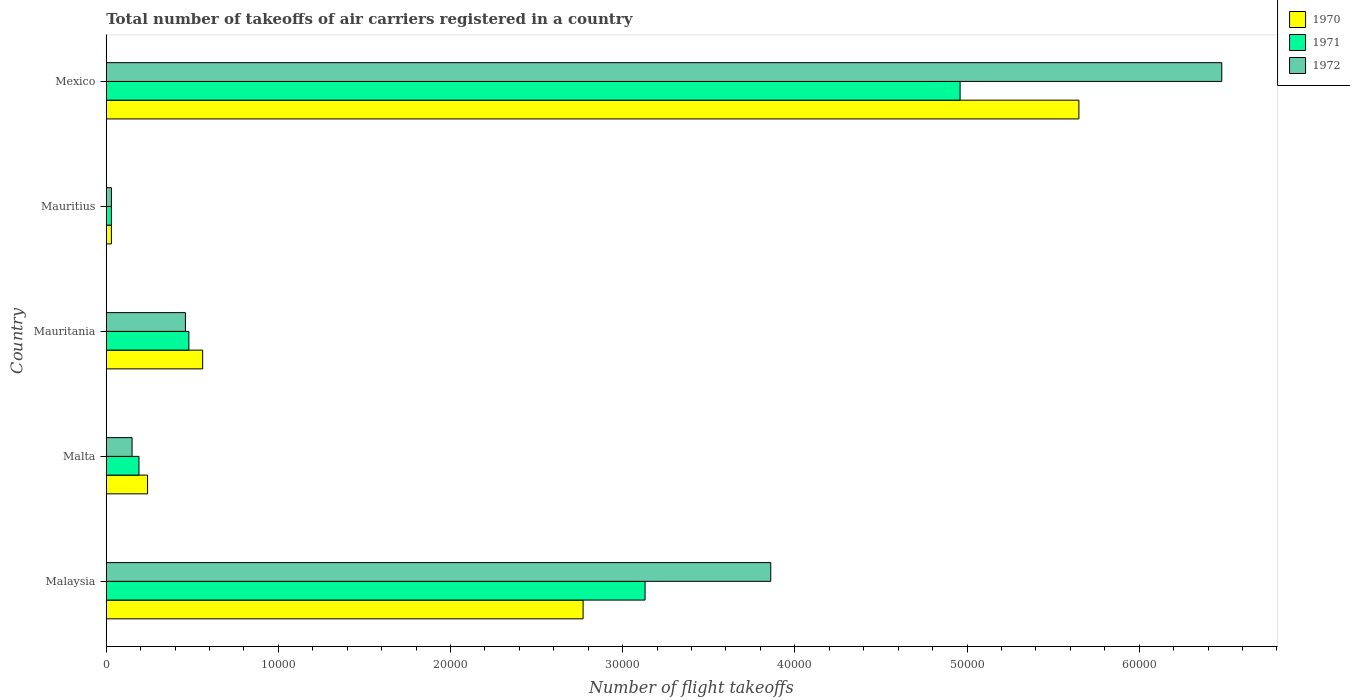Are the number of bars per tick equal to the number of legend labels?
Offer a very short reply. Yes. How many bars are there on the 4th tick from the top?
Ensure brevity in your answer.  3. How many bars are there on the 2nd tick from the bottom?
Offer a terse response. 3. What is the label of the 1st group of bars from the top?
Your answer should be very brief. Mexico. What is the total number of flight takeoffs in 1972 in Mauritania?
Offer a very short reply. 4600. Across all countries, what is the maximum total number of flight takeoffs in 1972?
Make the answer very short. 6.48e+04. Across all countries, what is the minimum total number of flight takeoffs in 1970?
Make the answer very short. 300. In which country was the total number of flight takeoffs in 1970 minimum?
Your answer should be compact. Mauritius. What is the total total number of flight takeoffs in 1971 in the graph?
Your answer should be compact. 8.79e+04. What is the difference between the total number of flight takeoffs in 1970 in Mauritius and that in Mexico?
Your answer should be very brief. -5.62e+04. What is the difference between the total number of flight takeoffs in 1971 in Malta and the total number of flight takeoffs in 1972 in Mexico?
Your answer should be compact. -6.29e+04. What is the average total number of flight takeoffs in 1972 per country?
Give a very brief answer. 2.20e+04. What is the difference between the total number of flight takeoffs in 1972 and total number of flight takeoffs in 1970 in Malta?
Give a very brief answer. -900. What is the ratio of the total number of flight takeoffs in 1970 in Malaysia to that in Mexico?
Keep it short and to the point. 0.49. Is the total number of flight takeoffs in 1971 in Malta less than that in Mexico?
Make the answer very short. Yes. What is the difference between the highest and the second highest total number of flight takeoffs in 1971?
Offer a very short reply. 1.83e+04. What is the difference between the highest and the lowest total number of flight takeoffs in 1970?
Your answer should be compact. 5.62e+04. In how many countries, is the total number of flight takeoffs in 1971 greater than the average total number of flight takeoffs in 1971 taken over all countries?
Keep it short and to the point. 2. Is the sum of the total number of flight takeoffs in 1971 in Mauritius and Mexico greater than the maximum total number of flight takeoffs in 1972 across all countries?
Your answer should be compact. No. What does the 2nd bar from the top in Malaysia represents?
Provide a short and direct response. 1971. What does the 2nd bar from the bottom in Malaysia represents?
Your answer should be compact. 1971. How many bars are there?
Your response must be concise. 15. Are all the bars in the graph horizontal?
Offer a terse response. Yes. How many countries are there in the graph?
Keep it short and to the point. 5. What is the difference between two consecutive major ticks on the X-axis?
Offer a terse response. 10000. Are the values on the major ticks of X-axis written in scientific E-notation?
Keep it short and to the point. No. Does the graph contain any zero values?
Offer a very short reply. No. Where does the legend appear in the graph?
Provide a short and direct response. Top right. How many legend labels are there?
Your response must be concise. 3. What is the title of the graph?
Keep it short and to the point. Total number of takeoffs of air carriers registered in a country. What is the label or title of the X-axis?
Provide a short and direct response. Number of flight takeoffs. What is the label or title of the Y-axis?
Offer a terse response. Country. What is the Number of flight takeoffs in 1970 in Malaysia?
Your answer should be compact. 2.77e+04. What is the Number of flight takeoffs in 1971 in Malaysia?
Make the answer very short. 3.13e+04. What is the Number of flight takeoffs in 1972 in Malaysia?
Your answer should be very brief. 3.86e+04. What is the Number of flight takeoffs of 1970 in Malta?
Your answer should be very brief. 2400. What is the Number of flight takeoffs of 1971 in Malta?
Keep it short and to the point. 1900. What is the Number of flight takeoffs of 1972 in Malta?
Keep it short and to the point. 1500. What is the Number of flight takeoffs in 1970 in Mauritania?
Provide a short and direct response. 5600. What is the Number of flight takeoffs of 1971 in Mauritania?
Make the answer very short. 4800. What is the Number of flight takeoffs in 1972 in Mauritania?
Provide a short and direct response. 4600. What is the Number of flight takeoffs in 1970 in Mauritius?
Provide a succinct answer. 300. What is the Number of flight takeoffs in 1971 in Mauritius?
Your response must be concise. 300. What is the Number of flight takeoffs in 1972 in Mauritius?
Give a very brief answer. 300. What is the Number of flight takeoffs of 1970 in Mexico?
Your response must be concise. 5.65e+04. What is the Number of flight takeoffs in 1971 in Mexico?
Your response must be concise. 4.96e+04. What is the Number of flight takeoffs of 1972 in Mexico?
Offer a terse response. 6.48e+04. Across all countries, what is the maximum Number of flight takeoffs of 1970?
Make the answer very short. 5.65e+04. Across all countries, what is the maximum Number of flight takeoffs of 1971?
Offer a very short reply. 4.96e+04. Across all countries, what is the maximum Number of flight takeoffs in 1972?
Offer a terse response. 6.48e+04. Across all countries, what is the minimum Number of flight takeoffs in 1970?
Offer a very short reply. 300. Across all countries, what is the minimum Number of flight takeoffs of 1971?
Your answer should be very brief. 300. Across all countries, what is the minimum Number of flight takeoffs of 1972?
Your answer should be compact. 300. What is the total Number of flight takeoffs in 1970 in the graph?
Offer a terse response. 9.25e+04. What is the total Number of flight takeoffs in 1971 in the graph?
Provide a succinct answer. 8.79e+04. What is the total Number of flight takeoffs of 1972 in the graph?
Provide a short and direct response. 1.10e+05. What is the difference between the Number of flight takeoffs of 1970 in Malaysia and that in Malta?
Your answer should be very brief. 2.53e+04. What is the difference between the Number of flight takeoffs of 1971 in Malaysia and that in Malta?
Keep it short and to the point. 2.94e+04. What is the difference between the Number of flight takeoffs of 1972 in Malaysia and that in Malta?
Your answer should be very brief. 3.71e+04. What is the difference between the Number of flight takeoffs in 1970 in Malaysia and that in Mauritania?
Provide a succinct answer. 2.21e+04. What is the difference between the Number of flight takeoffs in 1971 in Malaysia and that in Mauritania?
Give a very brief answer. 2.65e+04. What is the difference between the Number of flight takeoffs in 1972 in Malaysia and that in Mauritania?
Your answer should be compact. 3.40e+04. What is the difference between the Number of flight takeoffs of 1970 in Malaysia and that in Mauritius?
Ensure brevity in your answer.  2.74e+04. What is the difference between the Number of flight takeoffs in 1971 in Malaysia and that in Mauritius?
Your answer should be compact. 3.10e+04. What is the difference between the Number of flight takeoffs of 1972 in Malaysia and that in Mauritius?
Give a very brief answer. 3.83e+04. What is the difference between the Number of flight takeoffs of 1970 in Malaysia and that in Mexico?
Your answer should be very brief. -2.88e+04. What is the difference between the Number of flight takeoffs of 1971 in Malaysia and that in Mexico?
Make the answer very short. -1.83e+04. What is the difference between the Number of flight takeoffs of 1972 in Malaysia and that in Mexico?
Keep it short and to the point. -2.62e+04. What is the difference between the Number of flight takeoffs of 1970 in Malta and that in Mauritania?
Keep it short and to the point. -3200. What is the difference between the Number of flight takeoffs of 1971 in Malta and that in Mauritania?
Keep it short and to the point. -2900. What is the difference between the Number of flight takeoffs of 1972 in Malta and that in Mauritania?
Your answer should be very brief. -3100. What is the difference between the Number of flight takeoffs of 1970 in Malta and that in Mauritius?
Keep it short and to the point. 2100. What is the difference between the Number of flight takeoffs of 1971 in Malta and that in Mauritius?
Provide a succinct answer. 1600. What is the difference between the Number of flight takeoffs of 1972 in Malta and that in Mauritius?
Keep it short and to the point. 1200. What is the difference between the Number of flight takeoffs in 1970 in Malta and that in Mexico?
Ensure brevity in your answer.  -5.41e+04. What is the difference between the Number of flight takeoffs of 1971 in Malta and that in Mexico?
Offer a very short reply. -4.77e+04. What is the difference between the Number of flight takeoffs of 1972 in Malta and that in Mexico?
Your answer should be compact. -6.33e+04. What is the difference between the Number of flight takeoffs in 1970 in Mauritania and that in Mauritius?
Keep it short and to the point. 5300. What is the difference between the Number of flight takeoffs in 1971 in Mauritania and that in Mauritius?
Your answer should be compact. 4500. What is the difference between the Number of flight takeoffs of 1972 in Mauritania and that in Mauritius?
Make the answer very short. 4300. What is the difference between the Number of flight takeoffs in 1970 in Mauritania and that in Mexico?
Offer a terse response. -5.09e+04. What is the difference between the Number of flight takeoffs of 1971 in Mauritania and that in Mexico?
Keep it short and to the point. -4.48e+04. What is the difference between the Number of flight takeoffs of 1972 in Mauritania and that in Mexico?
Offer a very short reply. -6.02e+04. What is the difference between the Number of flight takeoffs of 1970 in Mauritius and that in Mexico?
Your answer should be compact. -5.62e+04. What is the difference between the Number of flight takeoffs in 1971 in Mauritius and that in Mexico?
Your response must be concise. -4.93e+04. What is the difference between the Number of flight takeoffs in 1972 in Mauritius and that in Mexico?
Provide a succinct answer. -6.45e+04. What is the difference between the Number of flight takeoffs in 1970 in Malaysia and the Number of flight takeoffs in 1971 in Malta?
Offer a very short reply. 2.58e+04. What is the difference between the Number of flight takeoffs in 1970 in Malaysia and the Number of flight takeoffs in 1972 in Malta?
Your answer should be compact. 2.62e+04. What is the difference between the Number of flight takeoffs in 1971 in Malaysia and the Number of flight takeoffs in 1972 in Malta?
Give a very brief answer. 2.98e+04. What is the difference between the Number of flight takeoffs of 1970 in Malaysia and the Number of flight takeoffs of 1971 in Mauritania?
Provide a short and direct response. 2.29e+04. What is the difference between the Number of flight takeoffs of 1970 in Malaysia and the Number of flight takeoffs of 1972 in Mauritania?
Your response must be concise. 2.31e+04. What is the difference between the Number of flight takeoffs in 1971 in Malaysia and the Number of flight takeoffs in 1972 in Mauritania?
Offer a very short reply. 2.67e+04. What is the difference between the Number of flight takeoffs in 1970 in Malaysia and the Number of flight takeoffs in 1971 in Mauritius?
Offer a terse response. 2.74e+04. What is the difference between the Number of flight takeoffs of 1970 in Malaysia and the Number of flight takeoffs of 1972 in Mauritius?
Give a very brief answer. 2.74e+04. What is the difference between the Number of flight takeoffs in 1971 in Malaysia and the Number of flight takeoffs in 1972 in Mauritius?
Offer a terse response. 3.10e+04. What is the difference between the Number of flight takeoffs of 1970 in Malaysia and the Number of flight takeoffs of 1971 in Mexico?
Offer a very short reply. -2.19e+04. What is the difference between the Number of flight takeoffs in 1970 in Malaysia and the Number of flight takeoffs in 1972 in Mexico?
Offer a very short reply. -3.71e+04. What is the difference between the Number of flight takeoffs of 1971 in Malaysia and the Number of flight takeoffs of 1972 in Mexico?
Keep it short and to the point. -3.35e+04. What is the difference between the Number of flight takeoffs in 1970 in Malta and the Number of flight takeoffs in 1971 in Mauritania?
Ensure brevity in your answer.  -2400. What is the difference between the Number of flight takeoffs in 1970 in Malta and the Number of flight takeoffs in 1972 in Mauritania?
Your response must be concise. -2200. What is the difference between the Number of flight takeoffs of 1971 in Malta and the Number of flight takeoffs of 1972 in Mauritania?
Offer a terse response. -2700. What is the difference between the Number of flight takeoffs of 1970 in Malta and the Number of flight takeoffs of 1971 in Mauritius?
Provide a short and direct response. 2100. What is the difference between the Number of flight takeoffs in 1970 in Malta and the Number of flight takeoffs in 1972 in Mauritius?
Give a very brief answer. 2100. What is the difference between the Number of flight takeoffs in 1971 in Malta and the Number of flight takeoffs in 1972 in Mauritius?
Ensure brevity in your answer.  1600. What is the difference between the Number of flight takeoffs in 1970 in Malta and the Number of flight takeoffs in 1971 in Mexico?
Offer a terse response. -4.72e+04. What is the difference between the Number of flight takeoffs in 1970 in Malta and the Number of flight takeoffs in 1972 in Mexico?
Your response must be concise. -6.24e+04. What is the difference between the Number of flight takeoffs of 1971 in Malta and the Number of flight takeoffs of 1972 in Mexico?
Keep it short and to the point. -6.29e+04. What is the difference between the Number of flight takeoffs of 1970 in Mauritania and the Number of flight takeoffs of 1971 in Mauritius?
Provide a succinct answer. 5300. What is the difference between the Number of flight takeoffs in 1970 in Mauritania and the Number of flight takeoffs in 1972 in Mauritius?
Your response must be concise. 5300. What is the difference between the Number of flight takeoffs in 1971 in Mauritania and the Number of flight takeoffs in 1972 in Mauritius?
Ensure brevity in your answer.  4500. What is the difference between the Number of flight takeoffs of 1970 in Mauritania and the Number of flight takeoffs of 1971 in Mexico?
Ensure brevity in your answer.  -4.40e+04. What is the difference between the Number of flight takeoffs of 1970 in Mauritania and the Number of flight takeoffs of 1972 in Mexico?
Your response must be concise. -5.92e+04. What is the difference between the Number of flight takeoffs of 1971 in Mauritania and the Number of flight takeoffs of 1972 in Mexico?
Offer a terse response. -6.00e+04. What is the difference between the Number of flight takeoffs of 1970 in Mauritius and the Number of flight takeoffs of 1971 in Mexico?
Give a very brief answer. -4.93e+04. What is the difference between the Number of flight takeoffs in 1970 in Mauritius and the Number of flight takeoffs in 1972 in Mexico?
Your answer should be compact. -6.45e+04. What is the difference between the Number of flight takeoffs in 1971 in Mauritius and the Number of flight takeoffs in 1972 in Mexico?
Ensure brevity in your answer.  -6.45e+04. What is the average Number of flight takeoffs of 1970 per country?
Ensure brevity in your answer.  1.85e+04. What is the average Number of flight takeoffs in 1971 per country?
Make the answer very short. 1.76e+04. What is the average Number of flight takeoffs in 1972 per country?
Ensure brevity in your answer.  2.20e+04. What is the difference between the Number of flight takeoffs in 1970 and Number of flight takeoffs in 1971 in Malaysia?
Your answer should be very brief. -3600. What is the difference between the Number of flight takeoffs in 1970 and Number of flight takeoffs in 1972 in Malaysia?
Ensure brevity in your answer.  -1.09e+04. What is the difference between the Number of flight takeoffs in 1971 and Number of flight takeoffs in 1972 in Malaysia?
Give a very brief answer. -7300. What is the difference between the Number of flight takeoffs in 1970 and Number of flight takeoffs in 1971 in Malta?
Your answer should be compact. 500. What is the difference between the Number of flight takeoffs of 1970 and Number of flight takeoffs of 1972 in Malta?
Make the answer very short. 900. What is the difference between the Number of flight takeoffs of 1970 and Number of flight takeoffs of 1971 in Mauritania?
Provide a succinct answer. 800. What is the difference between the Number of flight takeoffs in 1970 and Number of flight takeoffs in 1971 in Mauritius?
Your answer should be compact. 0. What is the difference between the Number of flight takeoffs of 1970 and Number of flight takeoffs of 1972 in Mauritius?
Provide a succinct answer. 0. What is the difference between the Number of flight takeoffs in 1970 and Number of flight takeoffs in 1971 in Mexico?
Your response must be concise. 6900. What is the difference between the Number of flight takeoffs in 1970 and Number of flight takeoffs in 1972 in Mexico?
Your answer should be compact. -8300. What is the difference between the Number of flight takeoffs of 1971 and Number of flight takeoffs of 1972 in Mexico?
Your response must be concise. -1.52e+04. What is the ratio of the Number of flight takeoffs of 1970 in Malaysia to that in Malta?
Ensure brevity in your answer.  11.54. What is the ratio of the Number of flight takeoffs in 1971 in Malaysia to that in Malta?
Keep it short and to the point. 16.47. What is the ratio of the Number of flight takeoffs of 1972 in Malaysia to that in Malta?
Keep it short and to the point. 25.73. What is the ratio of the Number of flight takeoffs in 1970 in Malaysia to that in Mauritania?
Make the answer very short. 4.95. What is the ratio of the Number of flight takeoffs of 1971 in Malaysia to that in Mauritania?
Ensure brevity in your answer.  6.52. What is the ratio of the Number of flight takeoffs of 1972 in Malaysia to that in Mauritania?
Provide a short and direct response. 8.39. What is the ratio of the Number of flight takeoffs of 1970 in Malaysia to that in Mauritius?
Provide a short and direct response. 92.33. What is the ratio of the Number of flight takeoffs of 1971 in Malaysia to that in Mauritius?
Offer a very short reply. 104.33. What is the ratio of the Number of flight takeoffs in 1972 in Malaysia to that in Mauritius?
Your answer should be very brief. 128.67. What is the ratio of the Number of flight takeoffs of 1970 in Malaysia to that in Mexico?
Make the answer very short. 0.49. What is the ratio of the Number of flight takeoffs in 1971 in Malaysia to that in Mexico?
Provide a short and direct response. 0.63. What is the ratio of the Number of flight takeoffs of 1972 in Malaysia to that in Mexico?
Your response must be concise. 0.6. What is the ratio of the Number of flight takeoffs in 1970 in Malta to that in Mauritania?
Provide a short and direct response. 0.43. What is the ratio of the Number of flight takeoffs of 1971 in Malta to that in Mauritania?
Make the answer very short. 0.4. What is the ratio of the Number of flight takeoffs in 1972 in Malta to that in Mauritania?
Ensure brevity in your answer.  0.33. What is the ratio of the Number of flight takeoffs in 1971 in Malta to that in Mauritius?
Keep it short and to the point. 6.33. What is the ratio of the Number of flight takeoffs of 1972 in Malta to that in Mauritius?
Your answer should be compact. 5. What is the ratio of the Number of flight takeoffs in 1970 in Malta to that in Mexico?
Give a very brief answer. 0.04. What is the ratio of the Number of flight takeoffs of 1971 in Malta to that in Mexico?
Give a very brief answer. 0.04. What is the ratio of the Number of flight takeoffs in 1972 in Malta to that in Mexico?
Provide a short and direct response. 0.02. What is the ratio of the Number of flight takeoffs in 1970 in Mauritania to that in Mauritius?
Keep it short and to the point. 18.67. What is the ratio of the Number of flight takeoffs in 1971 in Mauritania to that in Mauritius?
Offer a very short reply. 16. What is the ratio of the Number of flight takeoffs of 1972 in Mauritania to that in Mauritius?
Give a very brief answer. 15.33. What is the ratio of the Number of flight takeoffs of 1970 in Mauritania to that in Mexico?
Provide a succinct answer. 0.1. What is the ratio of the Number of flight takeoffs in 1971 in Mauritania to that in Mexico?
Offer a very short reply. 0.1. What is the ratio of the Number of flight takeoffs in 1972 in Mauritania to that in Mexico?
Ensure brevity in your answer.  0.07. What is the ratio of the Number of flight takeoffs in 1970 in Mauritius to that in Mexico?
Offer a very short reply. 0.01. What is the ratio of the Number of flight takeoffs in 1971 in Mauritius to that in Mexico?
Offer a very short reply. 0.01. What is the ratio of the Number of flight takeoffs in 1972 in Mauritius to that in Mexico?
Ensure brevity in your answer.  0. What is the difference between the highest and the second highest Number of flight takeoffs in 1970?
Keep it short and to the point. 2.88e+04. What is the difference between the highest and the second highest Number of flight takeoffs of 1971?
Provide a succinct answer. 1.83e+04. What is the difference between the highest and the second highest Number of flight takeoffs of 1972?
Your answer should be very brief. 2.62e+04. What is the difference between the highest and the lowest Number of flight takeoffs in 1970?
Your answer should be compact. 5.62e+04. What is the difference between the highest and the lowest Number of flight takeoffs of 1971?
Ensure brevity in your answer.  4.93e+04. What is the difference between the highest and the lowest Number of flight takeoffs in 1972?
Your response must be concise. 6.45e+04. 